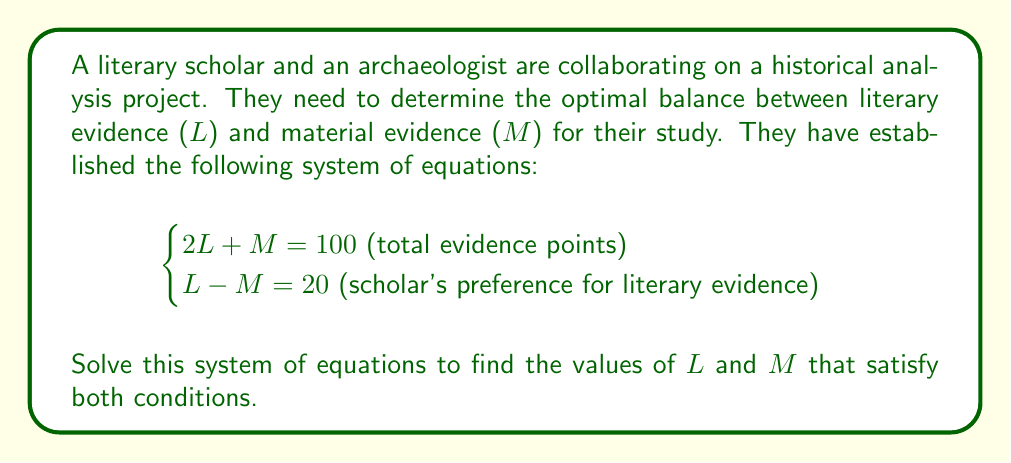Solve this math problem. To solve this system of equations, we'll use the substitution method:

1) From the second equation, we can express M in terms of L:
   $L - M = 20$
   $M = L - 20$

2) Substitute this expression for M into the first equation:
   $2L + (L - 20) = 100$

3) Simplify:
   $2L + L - 20 = 100$
   $3L - 20 = 100$

4) Add 20 to both sides:
   $3L = 120$

5) Divide both sides by 3:
   $L = 40$

6) Now that we know L, we can find M using either of the original equations. Let's use the second one:
   $L - M = 20$
   $40 - M = 20$
   $-M = -20$
   $M = 20$

7) Verify the solution by plugging these values back into both original equations:
   
   Equation 1: $2(40) + 20 = 100$ ✓
   Equation 2: $40 - 20 = 20$ ✓

This solution represents a balance where literary evidence (L) is given more weight than material evidence (M), aligning with the literary scholar's perspective while still incorporating material evidence.
Answer: $L = 40$, $M = 20$ 